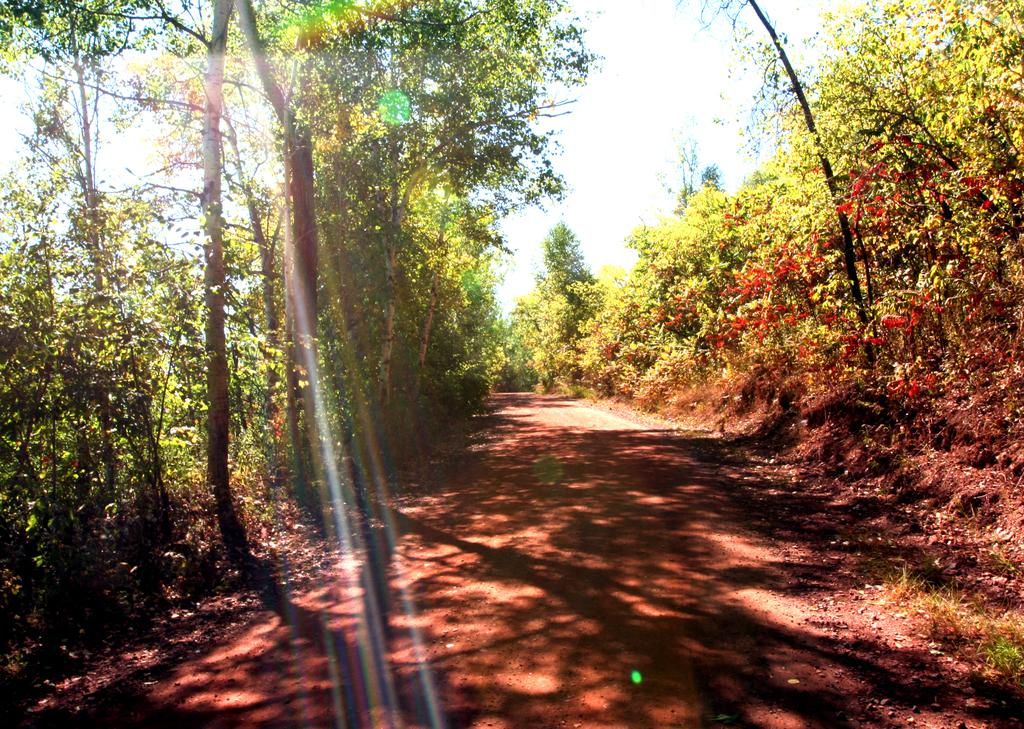What can be seen in the image that runs through the land in the image? There is a path in the image. What type of vegetation is present alongside the path? There are plants on both sides of the path. What other natural elements can be seen on the land in the image? There are trees on the land in the image. What is visible in the background of the image? The sky is visible in the background of the image. Can you tell me how many sisters are walking on the path in the image? There are no sisters present in the image; it only features a path with plants on both sides, trees, and the sky in the background. 